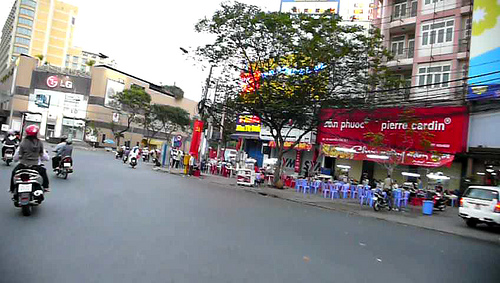What is the color of the car in the bottom of the image? The car visible at the bottom of the image is primarily white in color. 